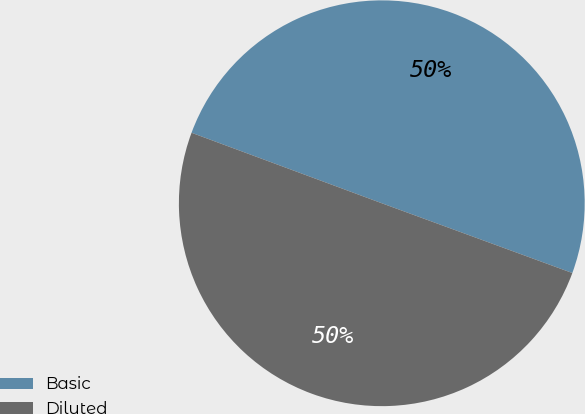<chart> <loc_0><loc_0><loc_500><loc_500><pie_chart><fcel>Basic<fcel>Diluted<nl><fcel>49.94%<fcel>50.06%<nl></chart> 